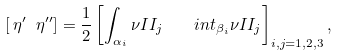Convert formula to latex. <formula><loc_0><loc_0><loc_500><loc_500>\left [ \, \eta ^ { \prime } \ \eta ^ { \prime \prime } \right ] = \frac { 1 } { 2 } \left [ \int _ { \alpha _ { i } } \nu I I _ { j } \quad i n t _ { \beta _ { i } } \nu I I _ { j } \right ] _ { i , j = 1 , 2 , 3 } ,</formula> 